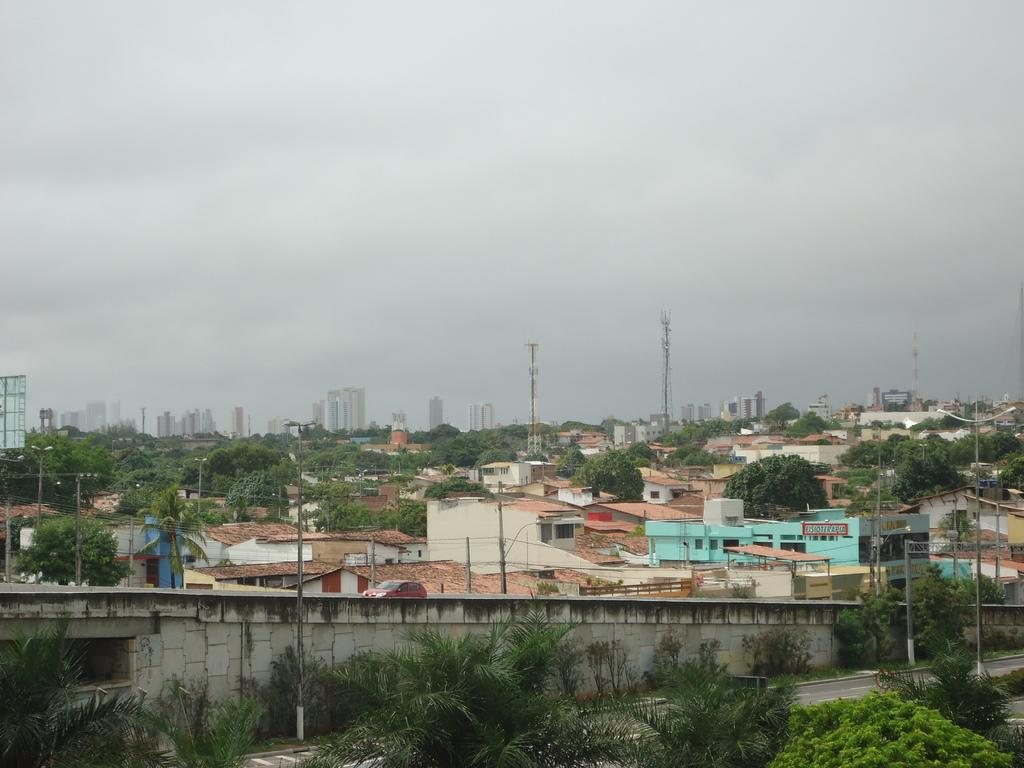What type of structures can be seen in the image? There are many buildings in the image. What other elements can be seen in the image besides buildings? There are trees, a road, light poles, and towers in the image. What is visible in the background of the image? The sky is visible in the background of the image. What is the price of the hole in the image? There is no hole present in the image, so it is not possible to determine its price. 